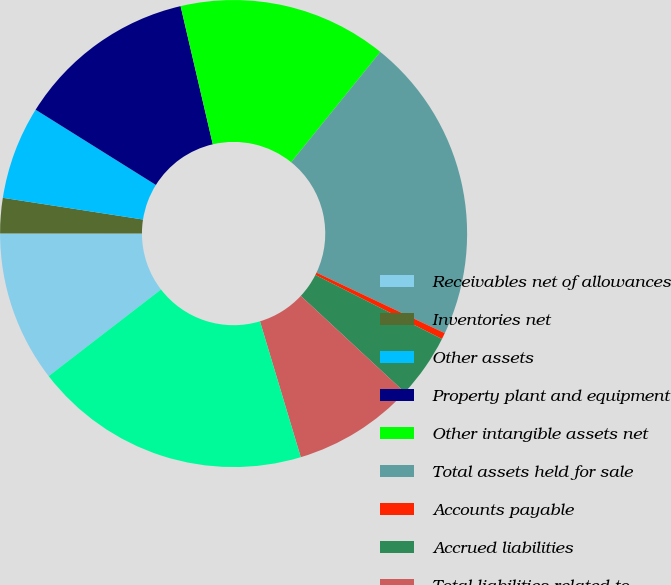Convert chart. <chart><loc_0><loc_0><loc_500><loc_500><pie_chart><fcel>Receivables net of allowances<fcel>Inventories net<fcel>Other assets<fcel>Property plant and equipment<fcel>Other intangible assets net<fcel>Total assets held for sale<fcel>Accounts payable<fcel>Accrued liabilities<fcel>Total liabilities related to<fcel>Net assets held for sale<nl><fcel>10.46%<fcel>2.44%<fcel>6.45%<fcel>12.46%<fcel>14.46%<fcel>21.2%<fcel>0.44%<fcel>4.45%<fcel>8.45%<fcel>19.19%<nl></chart> 